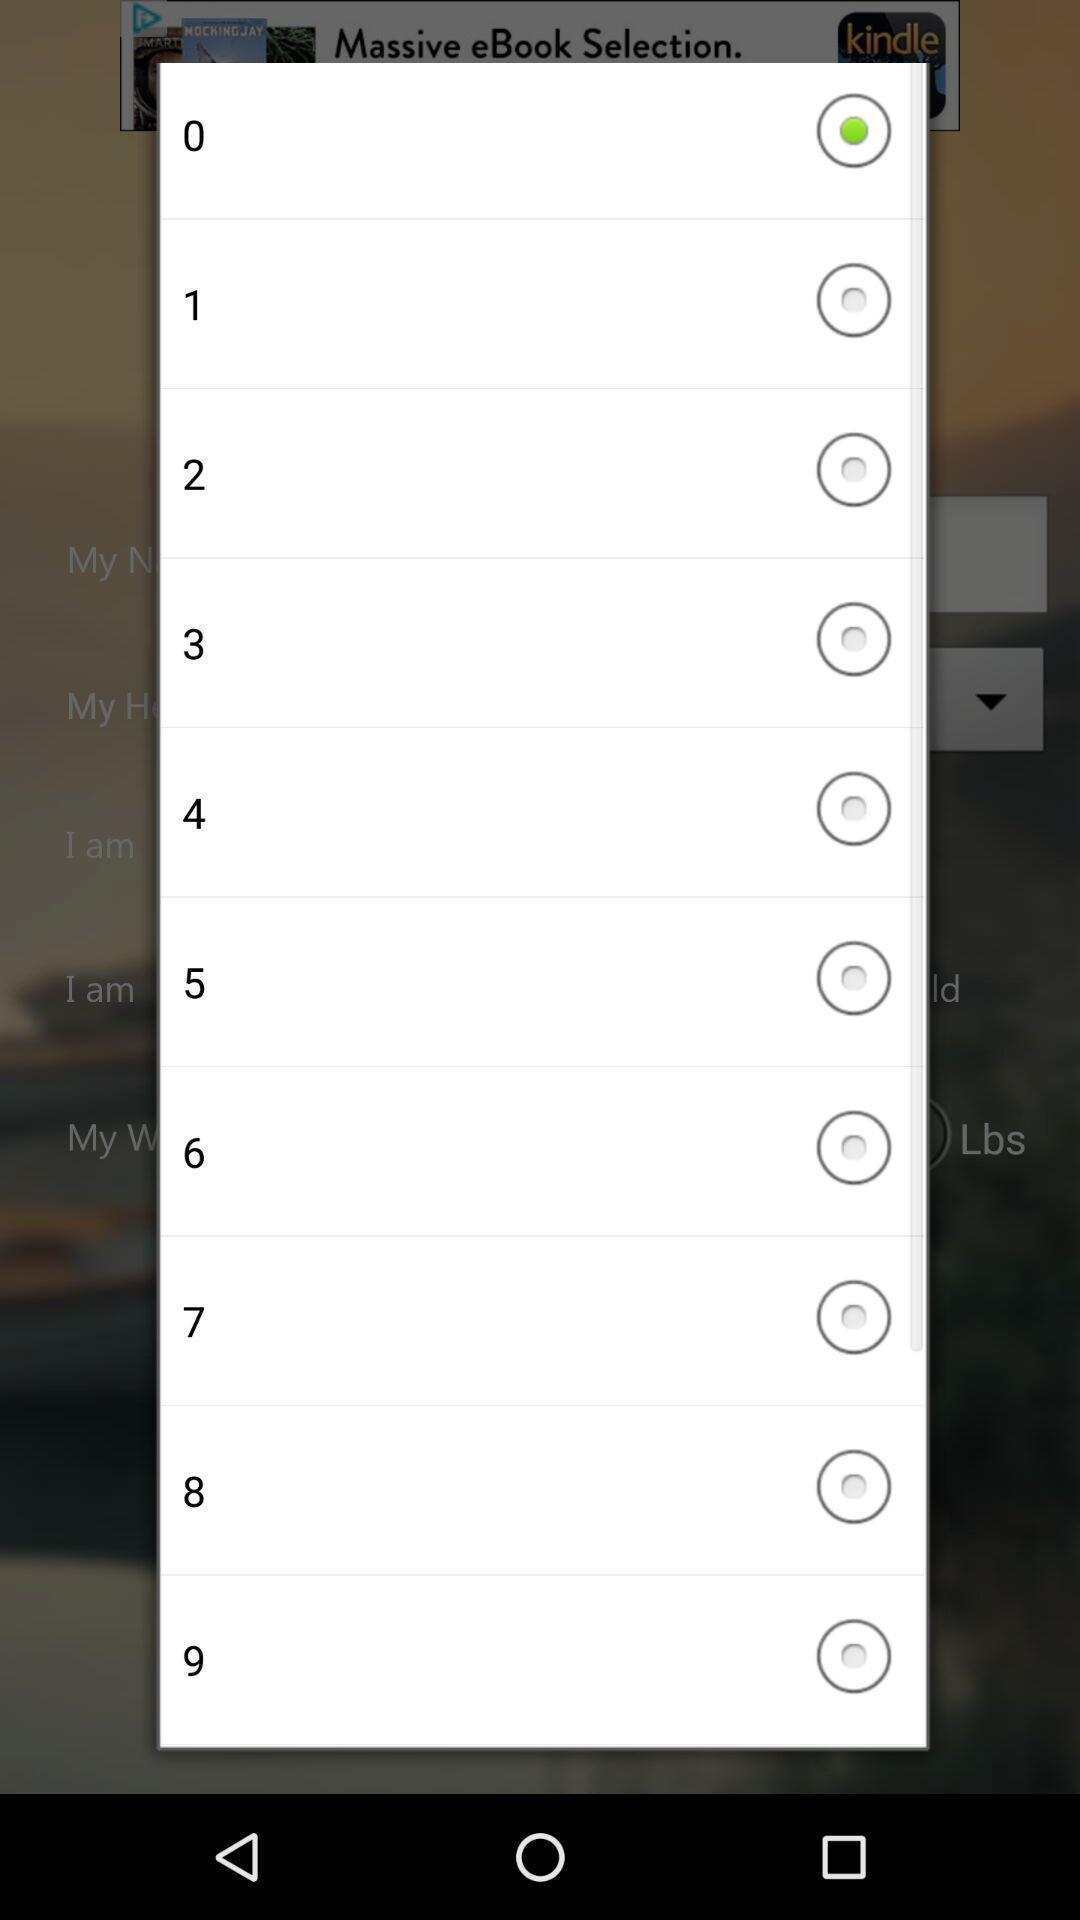Give me a summary of this screen capture. Popup to select from list of options. 